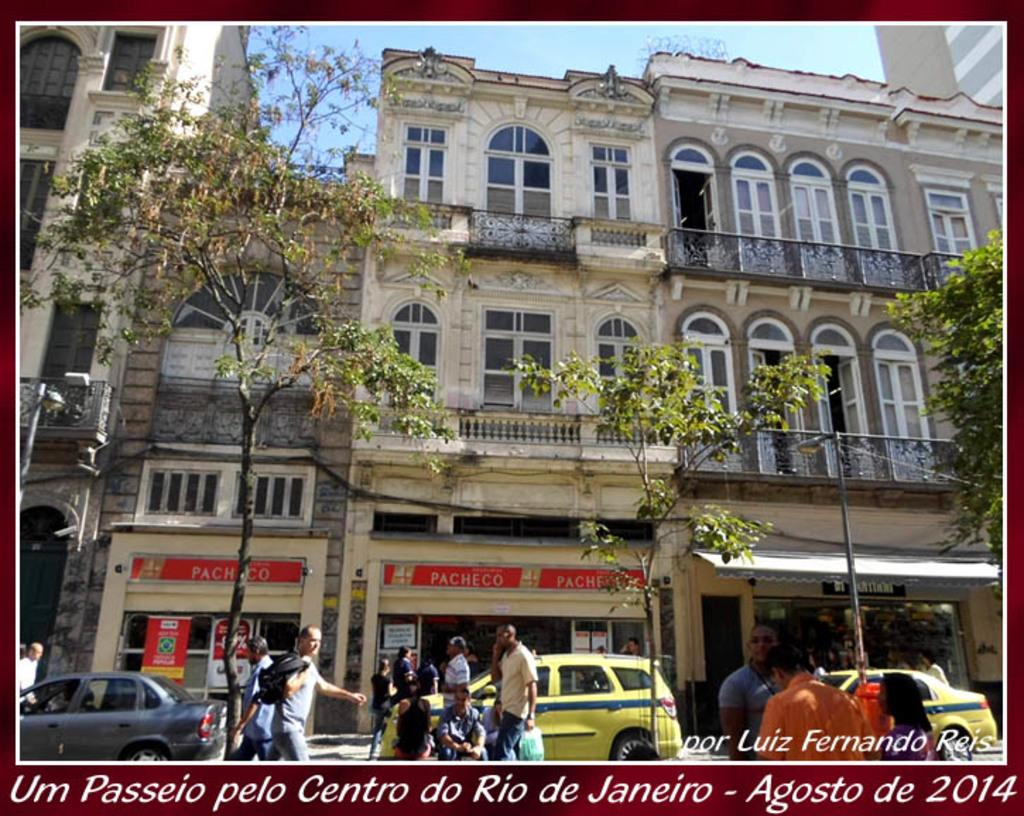<image>
Share a concise interpretation of the image provided. A picture of a building that are three stories with the words Um Passeio pelo Centro do Rio de Janeiro - Agosto de 2014 on the bottom 